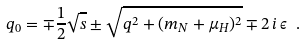<formula> <loc_0><loc_0><loc_500><loc_500>q _ { 0 } = \mp \frac { 1 } { 2 } \sqrt { s } \pm \sqrt { q ^ { 2 } + ( m _ { N } + \mu _ { H } ) ^ { 2 } } \mp 2 \, i \, \epsilon \ .</formula> 